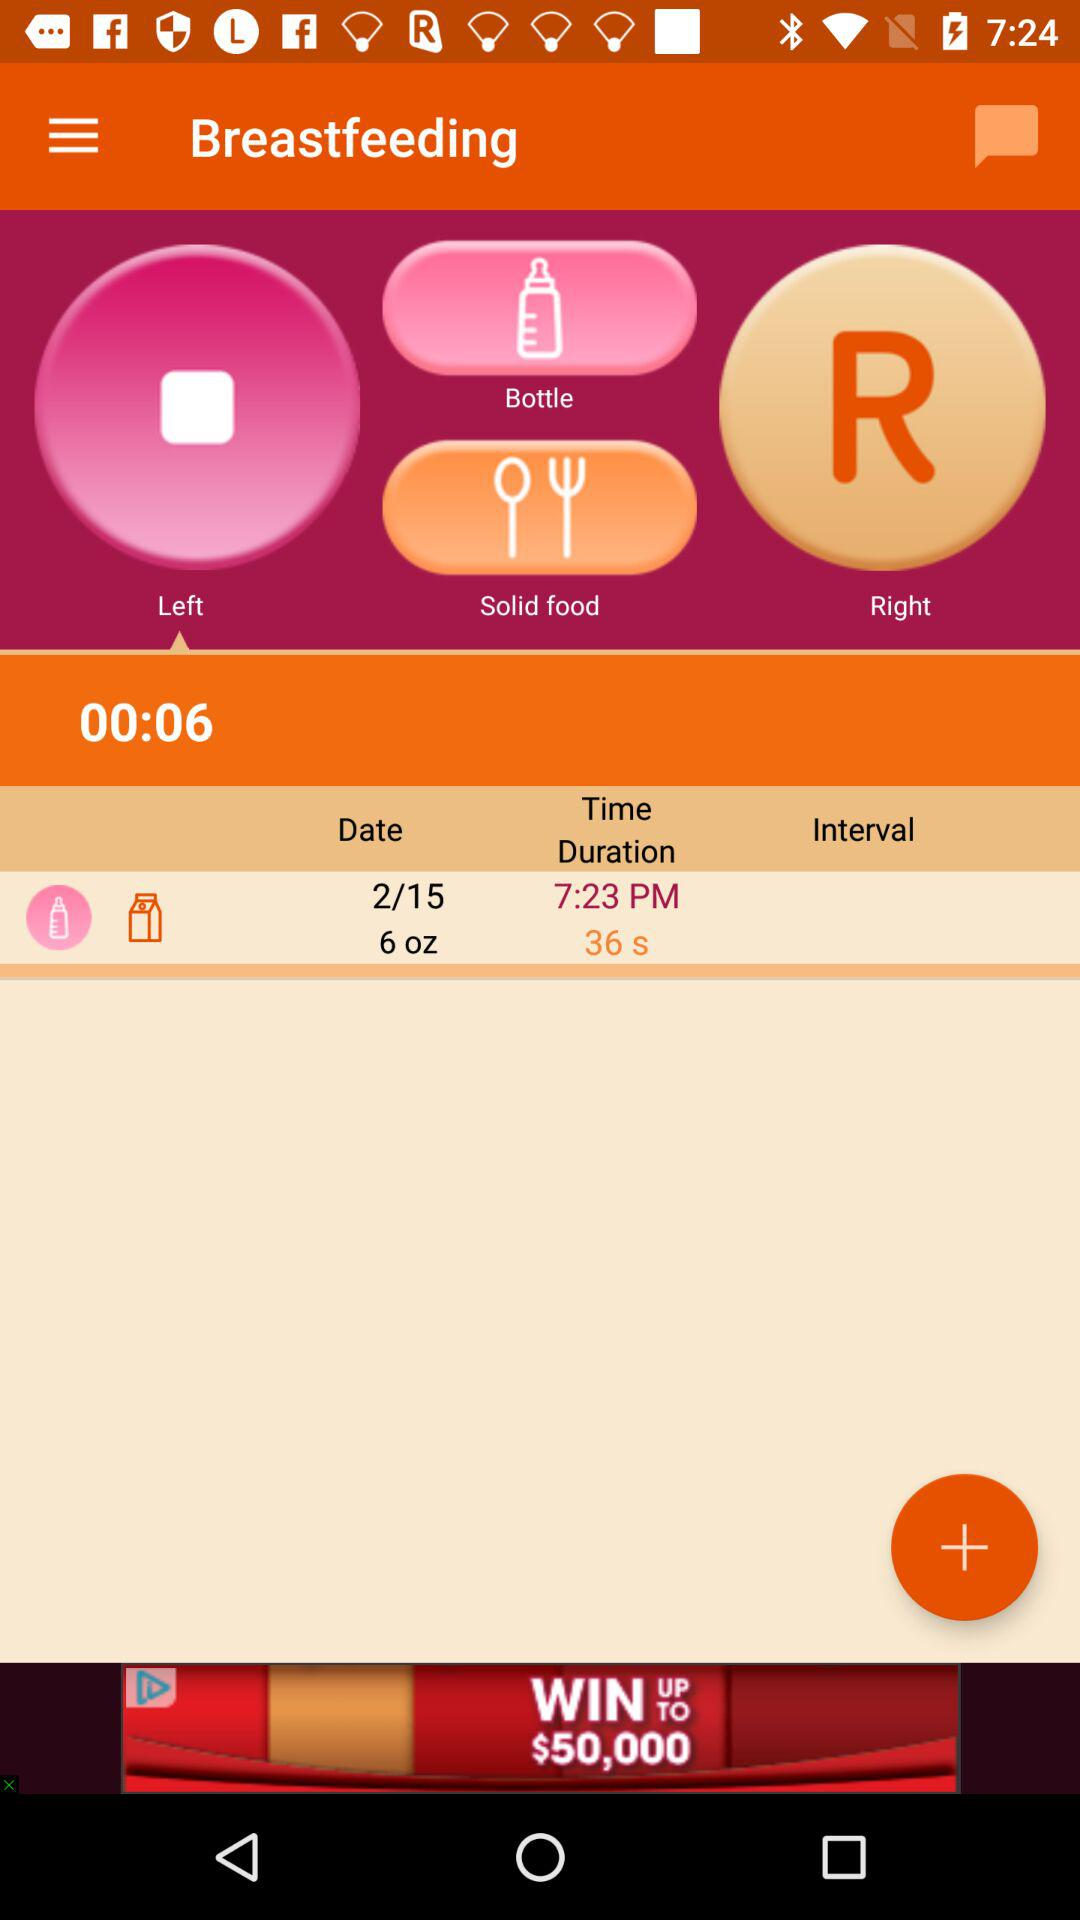What is the application name? The application name is "Breastfeeding". 